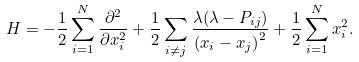Convert formula to latex. <formula><loc_0><loc_0><loc_500><loc_500>H = - \frac { 1 } { 2 } \sum _ { i = 1 } ^ { N } \frac { \partial ^ { 2 } } { \partial x _ { i } ^ { 2 } } + \frac { 1 } { 2 } \sum _ { i \neq j } \frac { \lambda ( \lambda - P _ { i j } ) } { \left ( x _ { i } - x _ { j } \right ) ^ { 2 } } + \frac { 1 } { 2 } \sum _ { i = 1 } ^ { N } x _ { i } ^ { 2 } .</formula> 